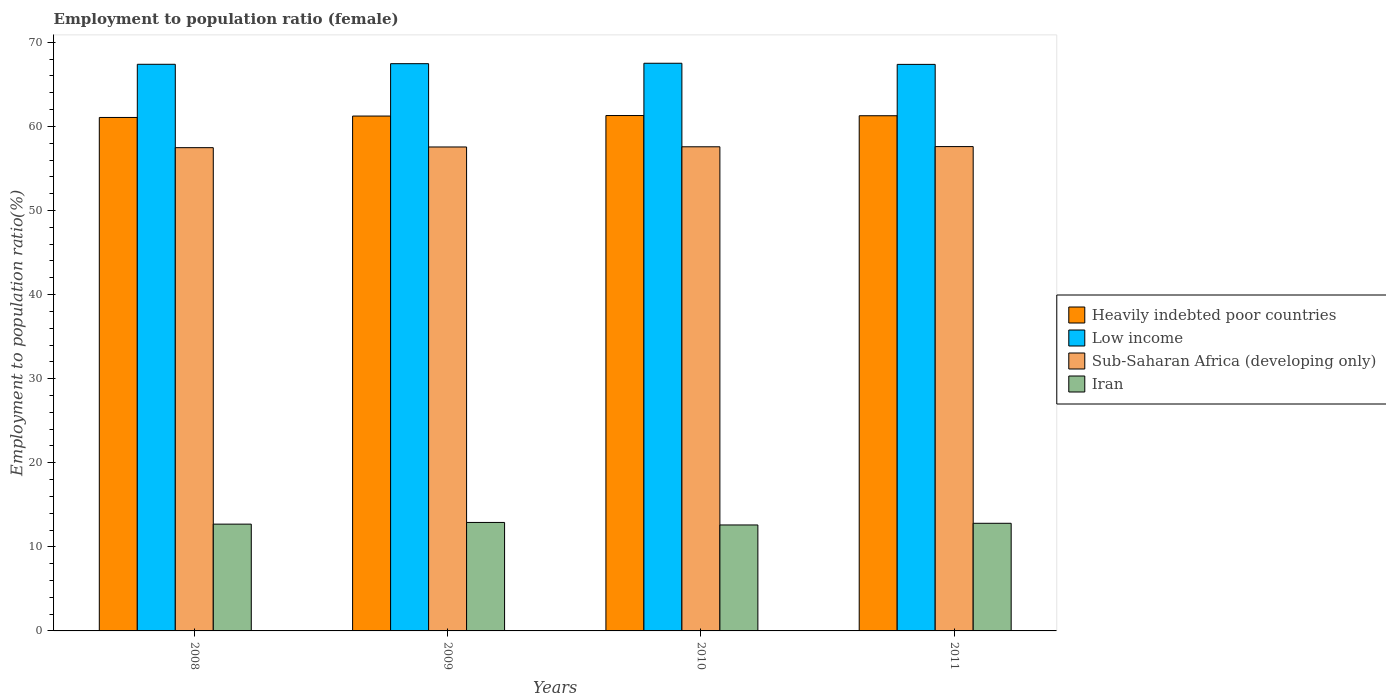How many groups of bars are there?
Offer a very short reply. 4. Are the number of bars on each tick of the X-axis equal?
Your answer should be very brief. Yes. What is the label of the 1st group of bars from the left?
Keep it short and to the point. 2008. What is the employment to population ratio in Low income in 2011?
Your answer should be very brief. 67.37. Across all years, what is the maximum employment to population ratio in Sub-Saharan Africa (developing only)?
Keep it short and to the point. 57.6. Across all years, what is the minimum employment to population ratio in Low income?
Your response must be concise. 67.37. In which year was the employment to population ratio in Low income minimum?
Offer a very short reply. 2011. What is the difference between the employment to population ratio in Sub-Saharan Africa (developing only) in 2009 and that in 2011?
Your answer should be compact. -0.05. What is the difference between the employment to population ratio in Heavily indebted poor countries in 2010 and the employment to population ratio in Iran in 2009?
Your answer should be compact. 48.39. What is the average employment to population ratio in Low income per year?
Your answer should be compact. 67.43. In the year 2011, what is the difference between the employment to population ratio in Sub-Saharan Africa (developing only) and employment to population ratio in Low income?
Your answer should be very brief. -9.78. In how many years, is the employment to population ratio in Sub-Saharan Africa (developing only) greater than 42 %?
Offer a very short reply. 4. What is the ratio of the employment to population ratio in Low income in 2009 to that in 2010?
Keep it short and to the point. 1. Is the difference between the employment to population ratio in Sub-Saharan Africa (developing only) in 2008 and 2009 greater than the difference between the employment to population ratio in Low income in 2008 and 2009?
Provide a short and direct response. No. What is the difference between the highest and the second highest employment to population ratio in Low income?
Provide a succinct answer. 0.05. What is the difference between the highest and the lowest employment to population ratio in Iran?
Ensure brevity in your answer.  0.3. Is it the case that in every year, the sum of the employment to population ratio in Sub-Saharan Africa (developing only) and employment to population ratio in Low income is greater than the sum of employment to population ratio in Heavily indebted poor countries and employment to population ratio in Iran?
Provide a succinct answer. No. What does the 3rd bar from the left in 2008 represents?
Your answer should be very brief. Sub-Saharan Africa (developing only). What does the 4th bar from the right in 2010 represents?
Give a very brief answer. Heavily indebted poor countries. What is the difference between two consecutive major ticks on the Y-axis?
Your response must be concise. 10. Does the graph contain grids?
Ensure brevity in your answer.  No. How many legend labels are there?
Your answer should be very brief. 4. How are the legend labels stacked?
Offer a terse response. Vertical. What is the title of the graph?
Offer a terse response. Employment to population ratio (female). Does "Korea (Republic)" appear as one of the legend labels in the graph?
Your response must be concise. No. What is the label or title of the Y-axis?
Make the answer very short. Employment to population ratio(%). What is the Employment to population ratio(%) in Heavily indebted poor countries in 2008?
Provide a short and direct response. 61.06. What is the Employment to population ratio(%) of Low income in 2008?
Your response must be concise. 67.38. What is the Employment to population ratio(%) of Sub-Saharan Africa (developing only) in 2008?
Offer a very short reply. 57.47. What is the Employment to population ratio(%) of Iran in 2008?
Make the answer very short. 12.7. What is the Employment to population ratio(%) of Heavily indebted poor countries in 2009?
Your answer should be very brief. 61.23. What is the Employment to population ratio(%) of Low income in 2009?
Your answer should be compact. 67.46. What is the Employment to population ratio(%) in Sub-Saharan Africa (developing only) in 2009?
Keep it short and to the point. 57.55. What is the Employment to population ratio(%) of Iran in 2009?
Offer a very short reply. 12.9. What is the Employment to population ratio(%) of Heavily indebted poor countries in 2010?
Offer a terse response. 61.29. What is the Employment to population ratio(%) in Low income in 2010?
Your answer should be compact. 67.51. What is the Employment to population ratio(%) in Sub-Saharan Africa (developing only) in 2010?
Provide a short and direct response. 57.57. What is the Employment to population ratio(%) of Iran in 2010?
Keep it short and to the point. 12.6. What is the Employment to population ratio(%) in Heavily indebted poor countries in 2011?
Provide a succinct answer. 61.26. What is the Employment to population ratio(%) of Low income in 2011?
Your response must be concise. 67.37. What is the Employment to population ratio(%) in Sub-Saharan Africa (developing only) in 2011?
Your answer should be compact. 57.6. What is the Employment to population ratio(%) in Iran in 2011?
Make the answer very short. 12.8. Across all years, what is the maximum Employment to population ratio(%) of Heavily indebted poor countries?
Your response must be concise. 61.29. Across all years, what is the maximum Employment to population ratio(%) of Low income?
Your answer should be compact. 67.51. Across all years, what is the maximum Employment to population ratio(%) of Sub-Saharan Africa (developing only)?
Your answer should be very brief. 57.6. Across all years, what is the maximum Employment to population ratio(%) in Iran?
Keep it short and to the point. 12.9. Across all years, what is the minimum Employment to population ratio(%) of Heavily indebted poor countries?
Make the answer very short. 61.06. Across all years, what is the minimum Employment to population ratio(%) in Low income?
Give a very brief answer. 67.37. Across all years, what is the minimum Employment to population ratio(%) of Sub-Saharan Africa (developing only)?
Your answer should be compact. 57.47. Across all years, what is the minimum Employment to population ratio(%) of Iran?
Provide a succinct answer. 12.6. What is the total Employment to population ratio(%) of Heavily indebted poor countries in the graph?
Your response must be concise. 244.84. What is the total Employment to population ratio(%) in Low income in the graph?
Your answer should be very brief. 269.72. What is the total Employment to population ratio(%) in Sub-Saharan Africa (developing only) in the graph?
Provide a succinct answer. 230.19. What is the difference between the Employment to population ratio(%) of Heavily indebted poor countries in 2008 and that in 2009?
Provide a succinct answer. -0.17. What is the difference between the Employment to population ratio(%) in Low income in 2008 and that in 2009?
Your answer should be compact. -0.07. What is the difference between the Employment to population ratio(%) in Sub-Saharan Africa (developing only) in 2008 and that in 2009?
Your response must be concise. -0.08. What is the difference between the Employment to population ratio(%) in Heavily indebted poor countries in 2008 and that in 2010?
Make the answer very short. -0.23. What is the difference between the Employment to population ratio(%) in Low income in 2008 and that in 2010?
Provide a succinct answer. -0.12. What is the difference between the Employment to population ratio(%) in Sub-Saharan Africa (developing only) in 2008 and that in 2010?
Your answer should be very brief. -0.1. What is the difference between the Employment to population ratio(%) of Iran in 2008 and that in 2010?
Offer a terse response. 0.1. What is the difference between the Employment to population ratio(%) of Heavily indebted poor countries in 2008 and that in 2011?
Make the answer very short. -0.2. What is the difference between the Employment to population ratio(%) of Low income in 2008 and that in 2011?
Provide a short and direct response. 0.01. What is the difference between the Employment to population ratio(%) of Sub-Saharan Africa (developing only) in 2008 and that in 2011?
Ensure brevity in your answer.  -0.13. What is the difference between the Employment to population ratio(%) of Heavily indebted poor countries in 2009 and that in 2010?
Give a very brief answer. -0.06. What is the difference between the Employment to population ratio(%) of Low income in 2009 and that in 2010?
Provide a succinct answer. -0.05. What is the difference between the Employment to population ratio(%) of Sub-Saharan Africa (developing only) in 2009 and that in 2010?
Provide a short and direct response. -0.02. What is the difference between the Employment to population ratio(%) of Iran in 2009 and that in 2010?
Your answer should be very brief. 0.3. What is the difference between the Employment to population ratio(%) in Heavily indebted poor countries in 2009 and that in 2011?
Your answer should be compact. -0.04. What is the difference between the Employment to population ratio(%) of Low income in 2009 and that in 2011?
Provide a succinct answer. 0.08. What is the difference between the Employment to population ratio(%) of Sub-Saharan Africa (developing only) in 2009 and that in 2011?
Keep it short and to the point. -0.05. What is the difference between the Employment to population ratio(%) in Iran in 2009 and that in 2011?
Ensure brevity in your answer.  0.1. What is the difference between the Employment to population ratio(%) of Heavily indebted poor countries in 2010 and that in 2011?
Offer a terse response. 0.03. What is the difference between the Employment to population ratio(%) of Low income in 2010 and that in 2011?
Your answer should be very brief. 0.13. What is the difference between the Employment to population ratio(%) of Sub-Saharan Africa (developing only) in 2010 and that in 2011?
Your answer should be compact. -0.02. What is the difference between the Employment to population ratio(%) in Heavily indebted poor countries in 2008 and the Employment to population ratio(%) in Low income in 2009?
Offer a very short reply. -6.4. What is the difference between the Employment to population ratio(%) in Heavily indebted poor countries in 2008 and the Employment to population ratio(%) in Sub-Saharan Africa (developing only) in 2009?
Offer a very short reply. 3.51. What is the difference between the Employment to population ratio(%) of Heavily indebted poor countries in 2008 and the Employment to population ratio(%) of Iran in 2009?
Offer a very short reply. 48.16. What is the difference between the Employment to population ratio(%) in Low income in 2008 and the Employment to population ratio(%) in Sub-Saharan Africa (developing only) in 2009?
Offer a very short reply. 9.83. What is the difference between the Employment to population ratio(%) in Low income in 2008 and the Employment to population ratio(%) in Iran in 2009?
Keep it short and to the point. 54.48. What is the difference between the Employment to population ratio(%) in Sub-Saharan Africa (developing only) in 2008 and the Employment to population ratio(%) in Iran in 2009?
Offer a very short reply. 44.57. What is the difference between the Employment to population ratio(%) in Heavily indebted poor countries in 2008 and the Employment to population ratio(%) in Low income in 2010?
Give a very brief answer. -6.45. What is the difference between the Employment to population ratio(%) of Heavily indebted poor countries in 2008 and the Employment to population ratio(%) of Sub-Saharan Africa (developing only) in 2010?
Provide a succinct answer. 3.49. What is the difference between the Employment to population ratio(%) in Heavily indebted poor countries in 2008 and the Employment to population ratio(%) in Iran in 2010?
Your response must be concise. 48.46. What is the difference between the Employment to population ratio(%) of Low income in 2008 and the Employment to population ratio(%) of Sub-Saharan Africa (developing only) in 2010?
Offer a terse response. 9.81. What is the difference between the Employment to population ratio(%) in Low income in 2008 and the Employment to population ratio(%) in Iran in 2010?
Ensure brevity in your answer.  54.78. What is the difference between the Employment to population ratio(%) in Sub-Saharan Africa (developing only) in 2008 and the Employment to population ratio(%) in Iran in 2010?
Your answer should be very brief. 44.87. What is the difference between the Employment to population ratio(%) in Heavily indebted poor countries in 2008 and the Employment to population ratio(%) in Low income in 2011?
Give a very brief answer. -6.31. What is the difference between the Employment to population ratio(%) of Heavily indebted poor countries in 2008 and the Employment to population ratio(%) of Sub-Saharan Africa (developing only) in 2011?
Provide a short and direct response. 3.46. What is the difference between the Employment to population ratio(%) of Heavily indebted poor countries in 2008 and the Employment to population ratio(%) of Iran in 2011?
Your response must be concise. 48.26. What is the difference between the Employment to population ratio(%) of Low income in 2008 and the Employment to population ratio(%) of Sub-Saharan Africa (developing only) in 2011?
Your answer should be very brief. 9.79. What is the difference between the Employment to population ratio(%) of Low income in 2008 and the Employment to population ratio(%) of Iran in 2011?
Your answer should be compact. 54.58. What is the difference between the Employment to population ratio(%) in Sub-Saharan Africa (developing only) in 2008 and the Employment to population ratio(%) in Iran in 2011?
Give a very brief answer. 44.67. What is the difference between the Employment to population ratio(%) of Heavily indebted poor countries in 2009 and the Employment to population ratio(%) of Low income in 2010?
Provide a succinct answer. -6.28. What is the difference between the Employment to population ratio(%) in Heavily indebted poor countries in 2009 and the Employment to population ratio(%) in Sub-Saharan Africa (developing only) in 2010?
Ensure brevity in your answer.  3.65. What is the difference between the Employment to population ratio(%) of Heavily indebted poor countries in 2009 and the Employment to population ratio(%) of Iran in 2010?
Keep it short and to the point. 48.63. What is the difference between the Employment to population ratio(%) of Low income in 2009 and the Employment to population ratio(%) of Sub-Saharan Africa (developing only) in 2010?
Provide a succinct answer. 9.88. What is the difference between the Employment to population ratio(%) in Low income in 2009 and the Employment to population ratio(%) in Iran in 2010?
Your answer should be compact. 54.86. What is the difference between the Employment to population ratio(%) of Sub-Saharan Africa (developing only) in 2009 and the Employment to population ratio(%) of Iran in 2010?
Make the answer very short. 44.95. What is the difference between the Employment to population ratio(%) of Heavily indebted poor countries in 2009 and the Employment to population ratio(%) of Low income in 2011?
Your answer should be compact. -6.15. What is the difference between the Employment to population ratio(%) of Heavily indebted poor countries in 2009 and the Employment to population ratio(%) of Sub-Saharan Africa (developing only) in 2011?
Offer a terse response. 3.63. What is the difference between the Employment to population ratio(%) in Heavily indebted poor countries in 2009 and the Employment to population ratio(%) in Iran in 2011?
Offer a terse response. 48.43. What is the difference between the Employment to population ratio(%) in Low income in 2009 and the Employment to population ratio(%) in Sub-Saharan Africa (developing only) in 2011?
Make the answer very short. 9.86. What is the difference between the Employment to population ratio(%) in Low income in 2009 and the Employment to population ratio(%) in Iran in 2011?
Give a very brief answer. 54.66. What is the difference between the Employment to population ratio(%) of Sub-Saharan Africa (developing only) in 2009 and the Employment to population ratio(%) of Iran in 2011?
Your answer should be very brief. 44.75. What is the difference between the Employment to population ratio(%) of Heavily indebted poor countries in 2010 and the Employment to population ratio(%) of Low income in 2011?
Offer a very short reply. -6.08. What is the difference between the Employment to population ratio(%) of Heavily indebted poor countries in 2010 and the Employment to population ratio(%) of Sub-Saharan Africa (developing only) in 2011?
Your answer should be very brief. 3.69. What is the difference between the Employment to population ratio(%) in Heavily indebted poor countries in 2010 and the Employment to population ratio(%) in Iran in 2011?
Provide a short and direct response. 48.49. What is the difference between the Employment to population ratio(%) of Low income in 2010 and the Employment to population ratio(%) of Sub-Saharan Africa (developing only) in 2011?
Your answer should be compact. 9.91. What is the difference between the Employment to population ratio(%) of Low income in 2010 and the Employment to population ratio(%) of Iran in 2011?
Your answer should be very brief. 54.71. What is the difference between the Employment to population ratio(%) in Sub-Saharan Africa (developing only) in 2010 and the Employment to population ratio(%) in Iran in 2011?
Offer a terse response. 44.77. What is the average Employment to population ratio(%) of Heavily indebted poor countries per year?
Keep it short and to the point. 61.21. What is the average Employment to population ratio(%) of Low income per year?
Make the answer very short. 67.43. What is the average Employment to population ratio(%) of Sub-Saharan Africa (developing only) per year?
Your response must be concise. 57.55. What is the average Employment to population ratio(%) in Iran per year?
Your answer should be very brief. 12.75. In the year 2008, what is the difference between the Employment to population ratio(%) in Heavily indebted poor countries and Employment to population ratio(%) in Low income?
Your answer should be compact. -6.32. In the year 2008, what is the difference between the Employment to population ratio(%) in Heavily indebted poor countries and Employment to population ratio(%) in Sub-Saharan Africa (developing only)?
Your response must be concise. 3.59. In the year 2008, what is the difference between the Employment to population ratio(%) in Heavily indebted poor countries and Employment to population ratio(%) in Iran?
Provide a succinct answer. 48.36. In the year 2008, what is the difference between the Employment to population ratio(%) of Low income and Employment to population ratio(%) of Sub-Saharan Africa (developing only)?
Your answer should be very brief. 9.91. In the year 2008, what is the difference between the Employment to population ratio(%) of Low income and Employment to population ratio(%) of Iran?
Keep it short and to the point. 54.68. In the year 2008, what is the difference between the Employment to population ratio(%) in Sub-Saharan Africa (developing only) and Employment to population ratio(%) in Iran?
Your answer should be compact. 44.77. In the year 2009, what is the difference between the Employment to population ratio(%) of Heavily indebted poor countries and Employment to population ratio(%) of Low income?
Offer a terse response. -6.23. In the year 2009, what is the difference between the Employment to population ratio(%) in Heavily indebted poor countries and Employment to population ratio(%) in Sub-Saharan Africa (developing only)?
Keep it short and to the point. 3.68. In the year 2009, what is the difference between the Employment to population ratio(%) of Heavily indebted poor countries and Employment to population ratio(%) of Iran?
Give a very brief answer. 48.33. In the year 2009, what is the difference between the Employment to population ratio(%) of Low income and Employment to population ratio(%) of Sub-Saharan Africa (developing only)?
Keep it short and to the point. 9.9. In the year 2009, what is the difference between the Employment to population ratio(%) of Low income and Employment to population ratio(%) of Iran?
Offer a terse response. 54.56. In the year 2009, what is the difference between the Employment to population ratio(%) in Sub-Saharan Africa (developing only) and Employment to population ratio(%) in Iran?
Ensure brevity in your answer.  44.65. In the year 2010, what is the difference between the Employment to population ratio(%) of Heavily indebted poor countries and Employment to population ratio(%) of Low income?
Your answer should be very brief. -6.22. In the year 2010, what is the difference between the Employment to population ratio(%) in Heavily indebted poor countries and Employment to population ratio(%) in Sub-Saharan Africa (developing only)?
Give a very brief answer. 3.72. In the year 2010, what is the difference between the Employment to population ratio(%) of Heavily indebted poor countries and Employment to population ratio(%) of Iran?
Provide a succinct answer. 48.69. In the year 2010, what is the difference between the Employment to population ratio(%) of Low income and Employment to population ratio(%) of Sub-Saharan Africa (developing only)?
Give a very brief answer. 9.93. In the year 2010, what is the difference between the Employment to population ratio(%) of Low income and Employment to population ratio(%) of Iran?
Your response must be concise. 54.91. In the year 2010, what is the difference between the Employment to population ratio(%) of Sub-Saharan Africa (developing only) and Employment to population ratio(%) of Iran?
Make the answer very short. 44.97. In the year 2011, what is the difference between the Employment to population ratio(%) of Heavily indebted poor countries and Employment to population ratio(%) of Low income?
Keep it short and to the point. -6.11. In the year 2011, what is the difference between the Employment to population ratio(%) in Heavily indebted poor countries and Employment to population ratio(%) in Sub-Saharan Africa (developing only)?
Provide a succinct answer. 3.67. In the year 2011, what is the difference between the Employment to population ratio(%) in Heavily indebted poor countries and Employment to population ratio(%) in Iran?
Your answer should be very brief. 48.46. In the year 2011, what is the difference between the Employment to population ratio(%) of Low income and Employment to population ratio(%) of Sub-Saharan Africa (developing only)?
Keep it short and to the point. 9.78. In the year 2011, what is the difference between the Employment to population ratio(%) of Low income and Employment to population ratio(%) of Iran?
Offer a very short reply. 54.57. In the year 2011, what is the difference between the Employment to population ratio(%) in Sub-Saharan Africa (developing only) and Employment to population ratio(%) in Iran?
Ensure brevity in your answer.  44.8. What is the ratio of the Employment to population ratio(%) of Heavily indebted poor countries in 2008 to that in 2009?
Give a very brief answer. 1. What is the ratio of the Employment to population ratio(%) of Iran in 2008 to that in 2009?
Offer a very short reply. 0.98. What is the ratio of the Employment to population ratio(%) of Heavily indebted poor countries in 2008 to that in 2010?
Your answer should be very brief. 1. What is the ratio of the Employment to population ratio(%) of Low income in 2008 to that in 2010?
Keep it short and to the point. 1. What is the ratio of the Employment to population ratio(%) of Sub-Saharan Africa (developing only) in 2008 to that in 2010?
Provide a succinct answer. 1. What is the ratio of the Employment to population ratio(%) in Iran in 2008 to that in 2010?
Your answer should be very brief. 1.01. What is the ratio of the Employment to population ratio(%) in Heavily indebted poor countries in 2008 to that in 2011?
Provide a short and direct response. 1. What is the ratio of the Employment to population ratio(%) in Low income in 2008 to that in 2011?
Your answer should be very brief. 1. What is the ratio of the Employment to population ratio(%) of Iran in 2008 to that in 2011?
Your answer should be very brief. 0.99. What is the ratio of the Employment to population ratio(%) of Heavily indebted poor countries in 2009 to that in 2010?
Keep it short and to the point. 1. What is the ratio of the Employment to population ratio(%) of Low income in 2009 to that in 2010?
Your answer should be compact. 1. What is the ratio of the Employment to population ratio(%) of Iran in 2009 to that in 2010?
Keep it short and to the point. 1.02. What is the ratio of the Employment to population ratio(%) of Heavily indebted poor countries in 2009 to that in 2011?
Your answer should be compact. 1. What is the ratio of the Employment to population ratio(%) of Sub-Saharan Africa (developing only) in 2009 to that in 2011?
Make the answer very short. 1. What is the ratio of the Employment to population ratio(%) of Iran in 2009 to that in 2011?
Offer a very short reply. 1.01. What is the ratio of the Employment to population ratio(%) of Iran in 2010 to that in 2011?
Provide a succinct answer. 0.98. What is the difference between the highest and the second highest Employment to population ratio(%) of Heavily indebted poor countries?
Offer a very short reply. 0.03. What is the difference between the highest and the second highest Employment to population ratio(%) of Low income?
Your answer should be compact. 0.05. What is the difference between the highest and the second highest Employment to population ratio(%) of Sub-Saharan Africa (developing only)?
Offer a terse response. 0.02. What is the difference between the highest and the second highest Employment to population ratio(%) in Iran?
Give a very brief answer. 0.1. What is the difference between the highest and the lowest Employment to population ratio(%) in Heavily indebted poor countries?
Your response must be concise. 0.23. What is the difference between the highest and the lowest Employment to population ratio(%) of Low income?
Offer a very short reply. 0.13. What is the difference between the highest and the lowest Employment to population ratio(%) in Sub-Saharan Africa (developing only)?
Give a very brief answer. 0.13. What is the difference between the highest and the lowest Employment to population ratio(%) in Iran?
Provide a short and direct response. 0.3. 